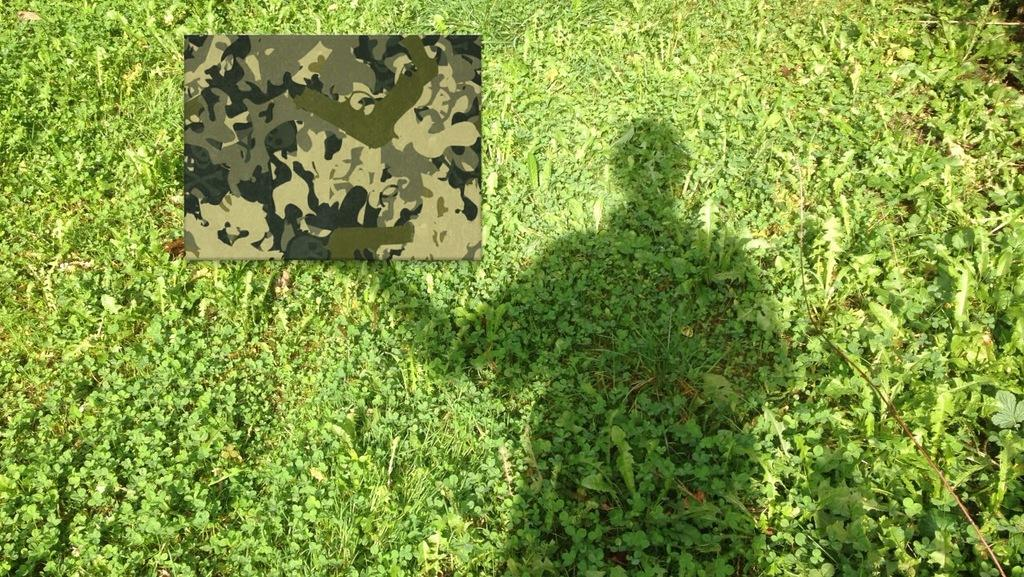What type of living organisms can be seen in the image? Plants can be seen in the image. What is the other object visible in the image? There is a cloth in the image. Can you describe any other element in the image? There is a shadow of a person in the image. What historical event is being commemorated by the cream in the image? There is no cream present in the image, and therefore no historical event can be associated with it. 